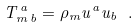Convert formula to latex. <formula><loc_0><loc_0><loc_500><loc_500>T _ { m \, b } ^ { \, a } = \rho _ { m } u ^ { a } u _ { b } \ .</formula> 